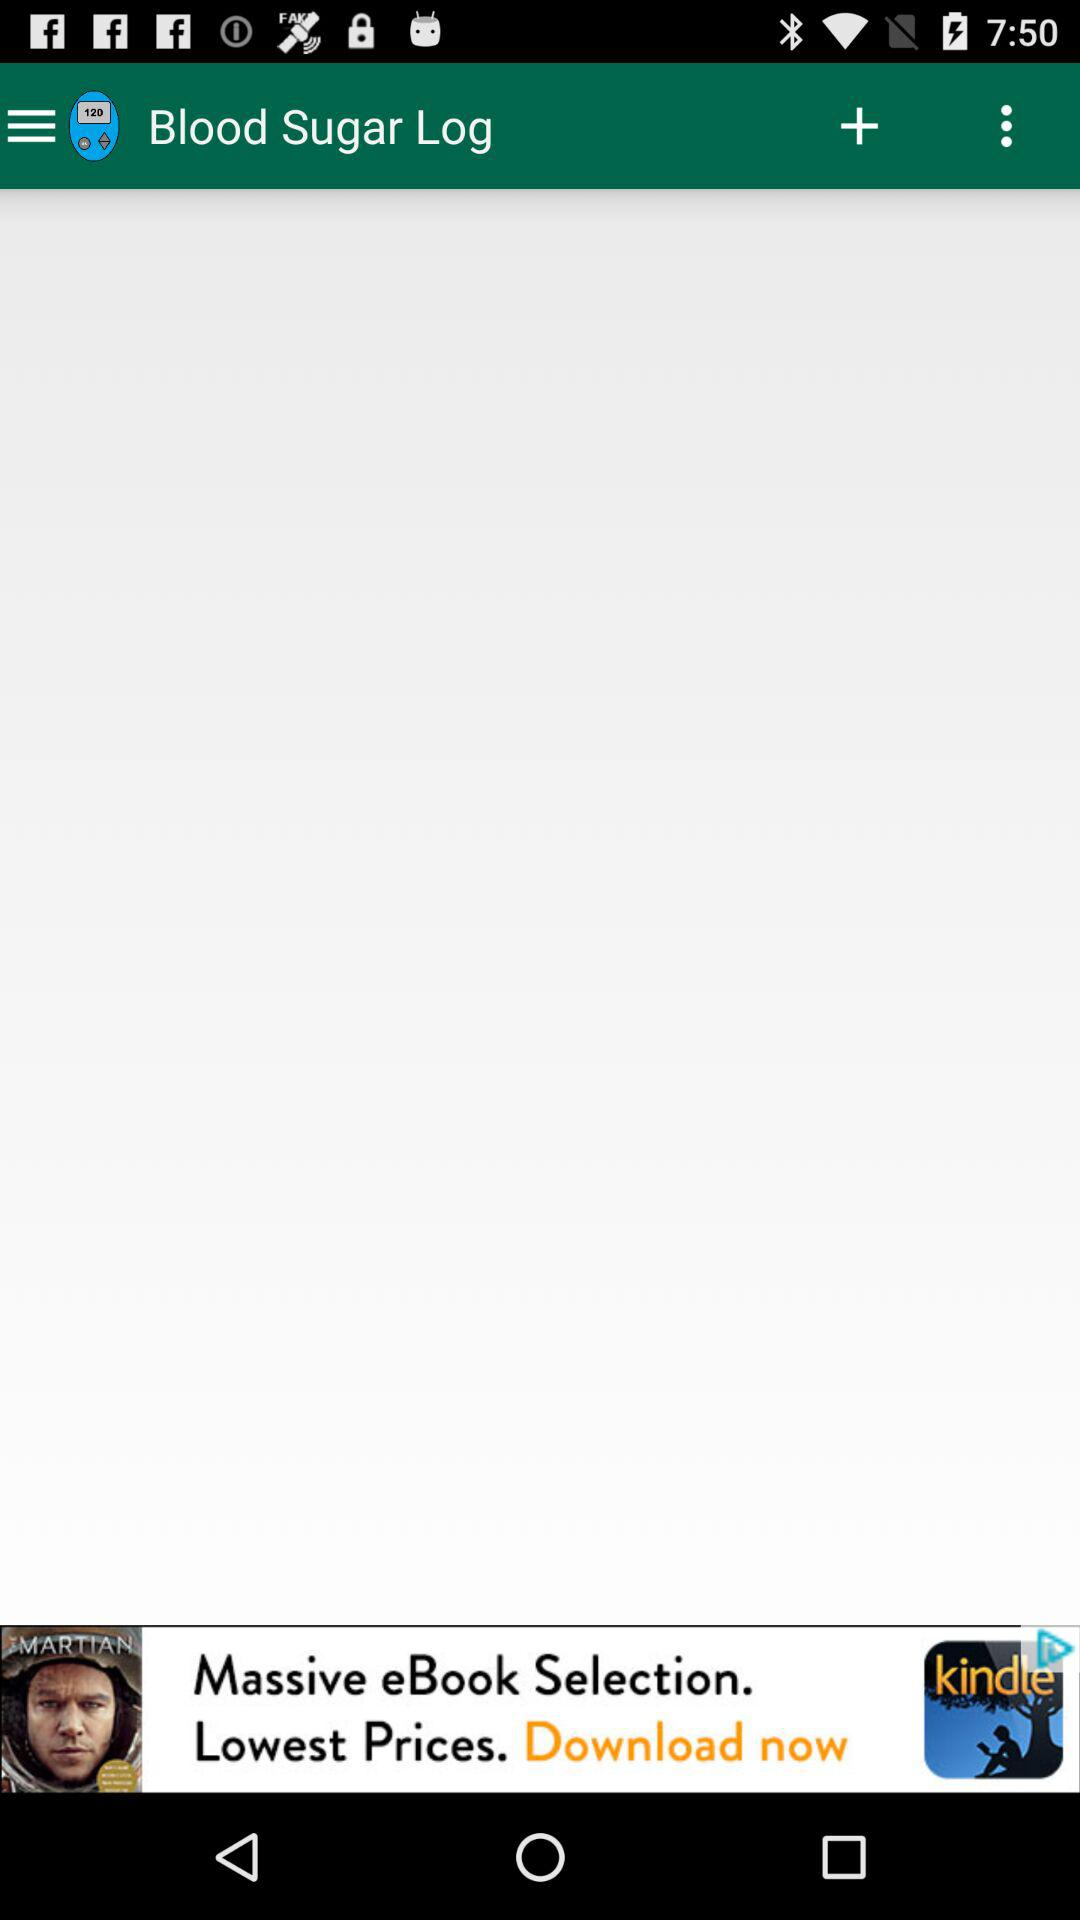What is the name of the application? The application name is "Blood Sugar Log". 